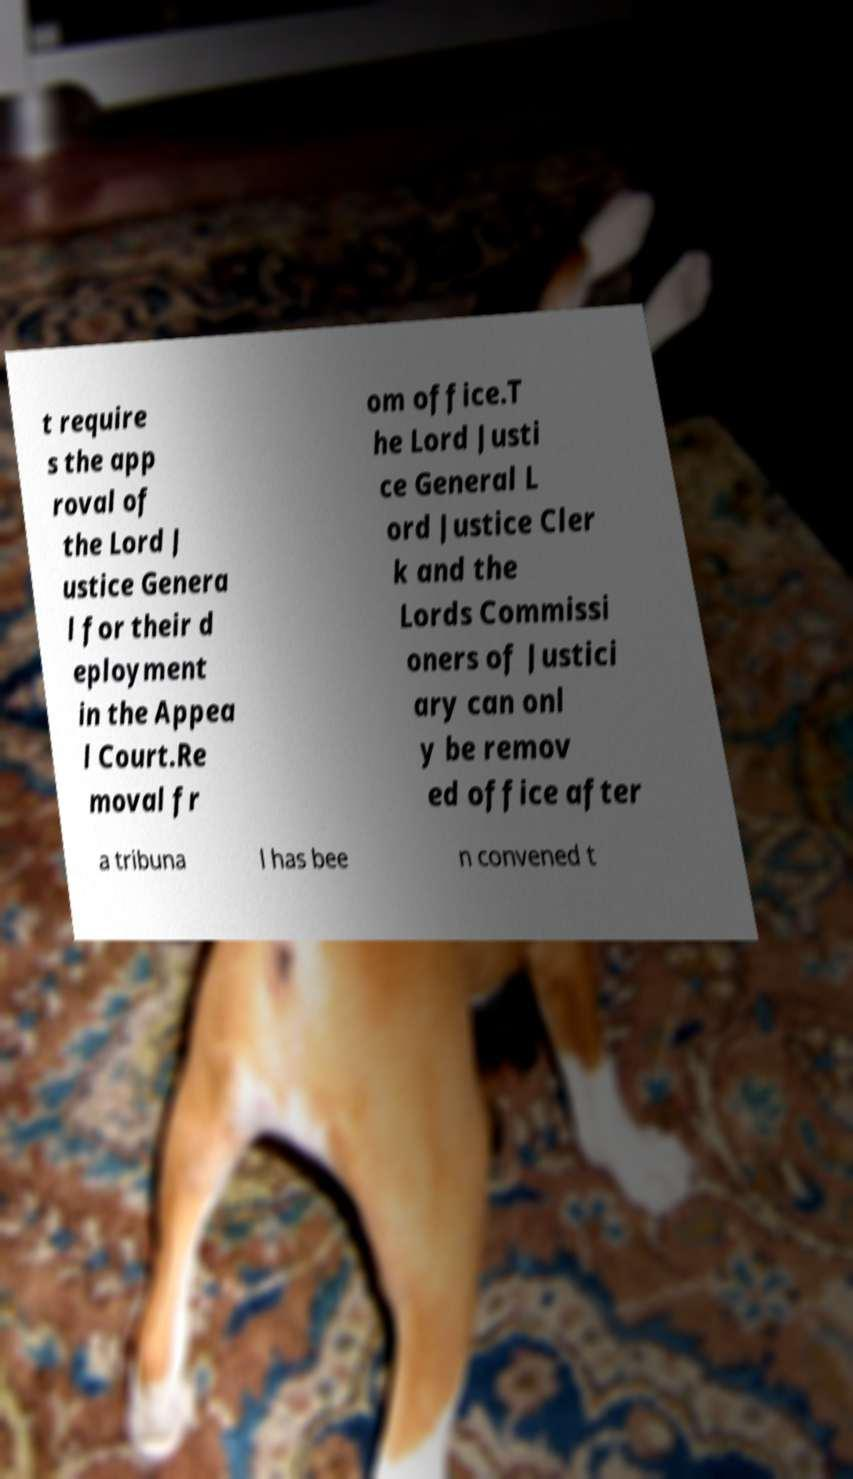Could you extract and type out the text from this image? t require s the app roval of the Lord J ustice Genera l for their d eployment in the Appea l Court.Re moval fr om office.T he Lord Justi ce General L ord Justice Cler k and the Lords Commissi oners of Justici ary can onl y be remov ed office after a tribuna l has bee n convened t 